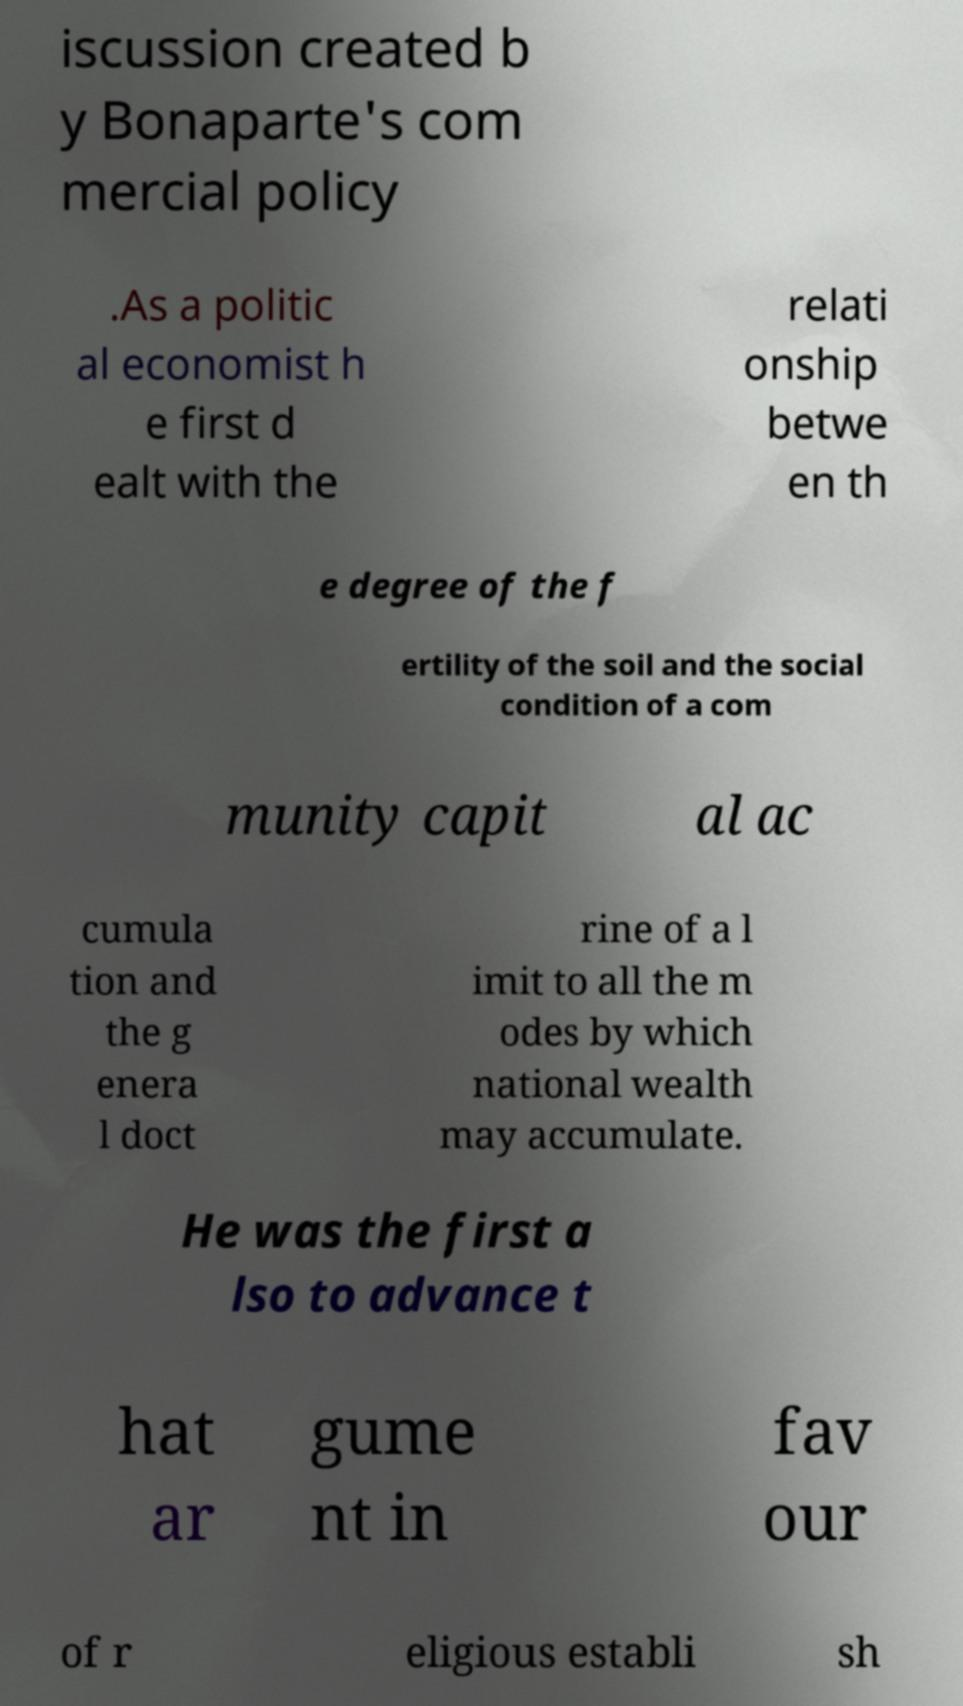For documentation purposes, I need the text within this image transcribed. Could you provide that? iscussion created b y Bonaparte's com mercial policy .As a politic al economist h e first d ealt with the relati onship betwe en th e degree of the f ertility of the soil and the social condition of a com munity capit al ac cumula tion and the g enera l doct rine of a l imit to all the m odes by which national wealth may accumulate. He was the first a lso to advance t hat ar gume nt in fav our of r eligious establi sh 